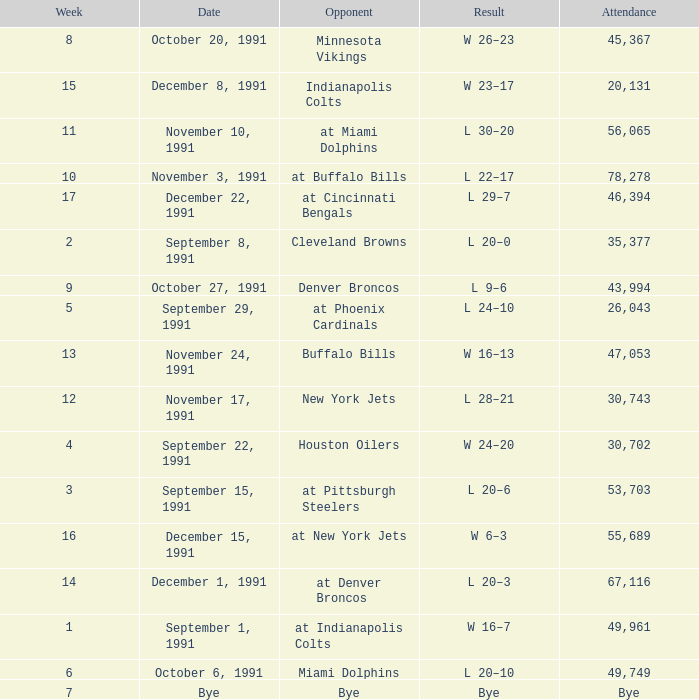What was the result of the game on December 22, 1991? L 29–7. 